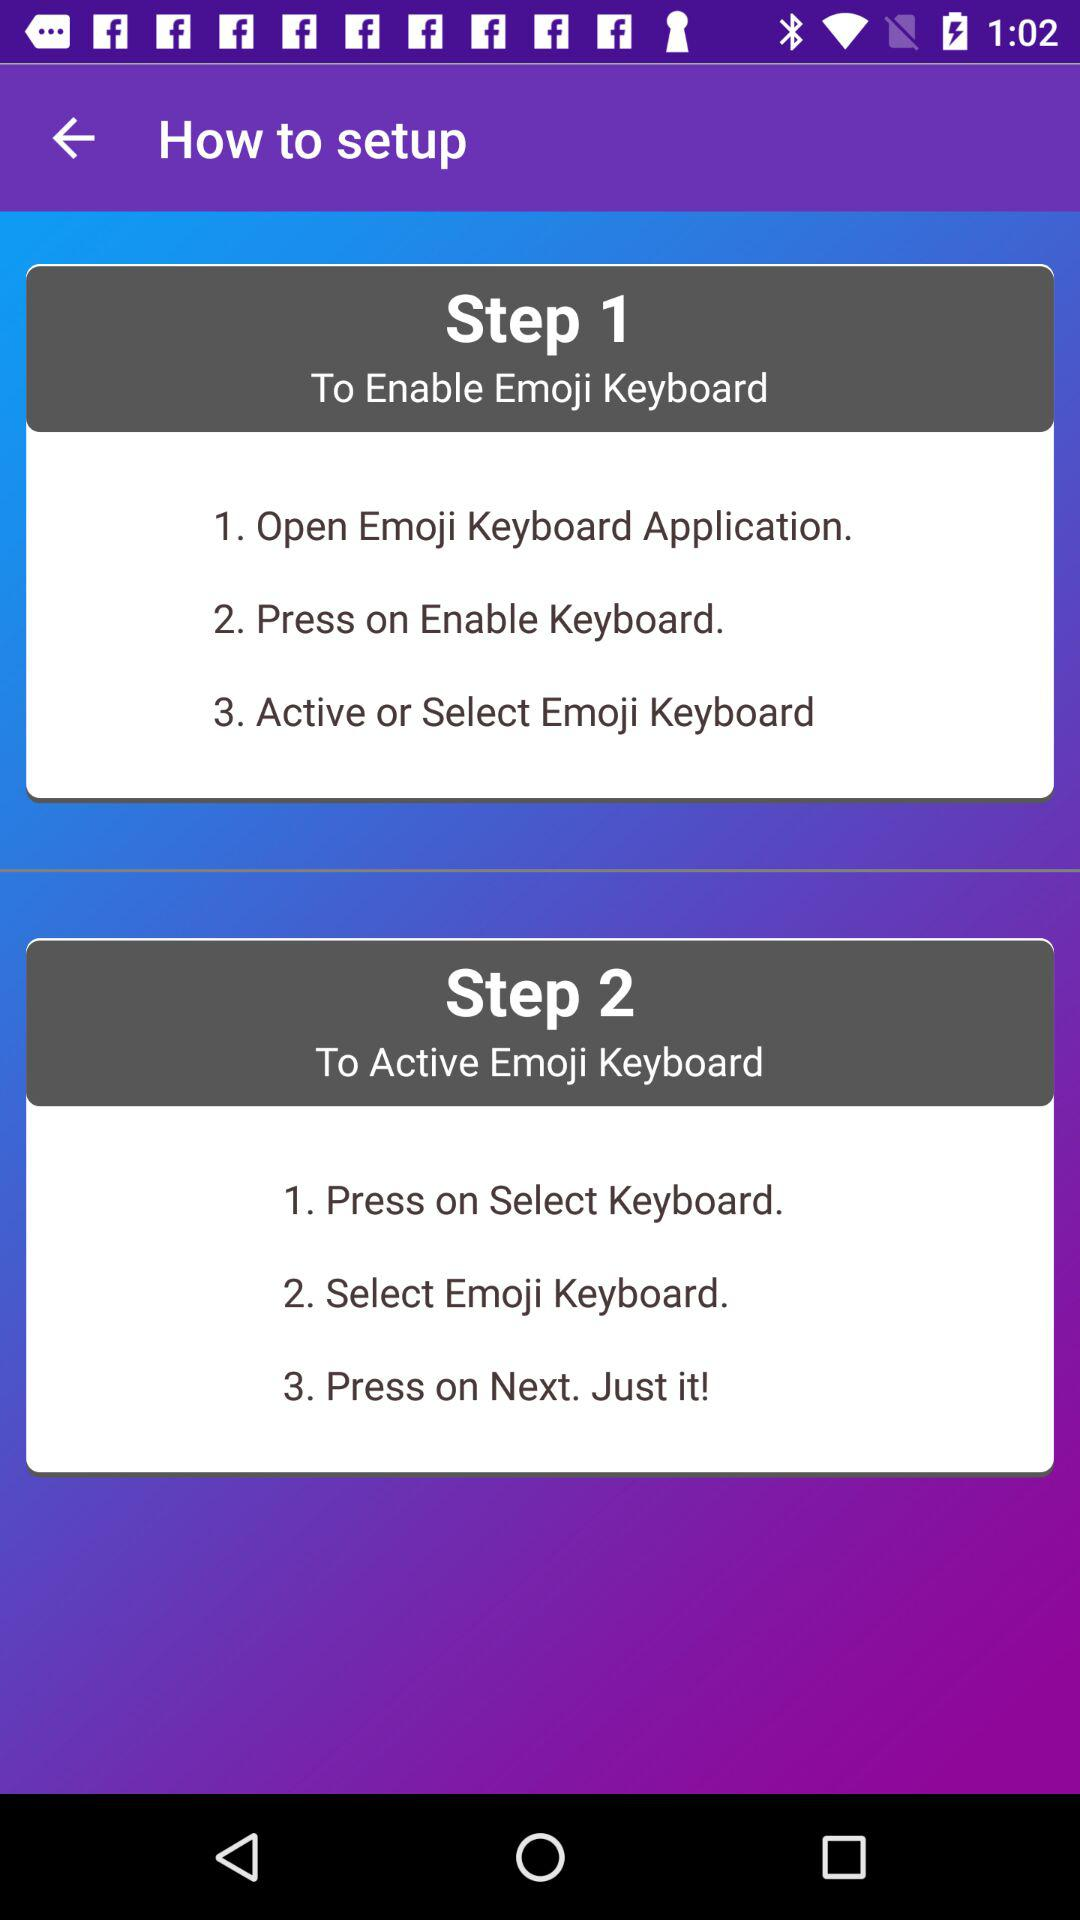What does Step 2 include? Step 2 includes "Press on Select Keyboard", "Select Emoji Keyboard" and "Press on Next. Just it!". 